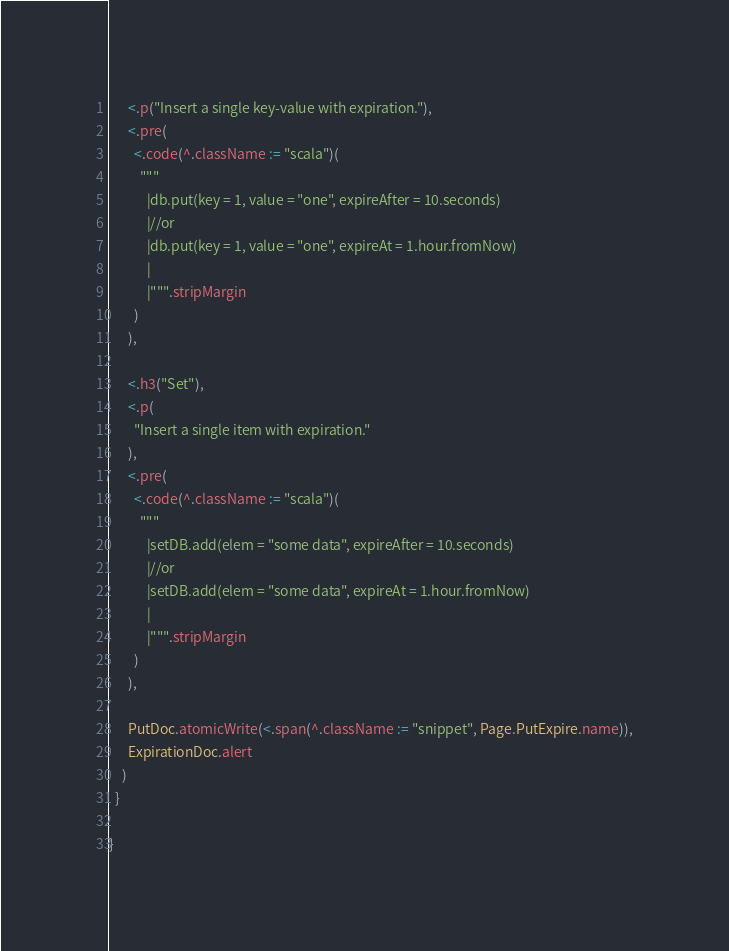Convert code to text. <code><loc_0><loc_0><loc_500><loc_500><_Scala_>      <.p("Insert a single key-value with expiration."),
      <.pre(
        <.code(^.className := "scala")(
          """
            |db.put(key = 1, value = "one", expireAfter = 10.seconds)
            |//or
            |db.put(key = 1, value = "one", expireAt = 1.hour.fromNow)
            |
            |""".stripMargin
        )
      ),

      <.h3("Set"),
      <.p(
        "Insert a single item with expiration."
      ),
      <.pre(
        <.code(^.className := "scala")(
          """
            |setDB.add(elem = "some data", expireAfter = 10.seconds)
            |//or
            |setDB.add(elem = "some data", expireAt = 1.hour.fromNow)
            |
            |""".stripMargin
        )
      ),

      PutDoc.atomicWrite(<.span(^.className := "snippet", Page.PutExpire.name)),
      ExpirationDoc.alert
    )
  }

}
</code> 